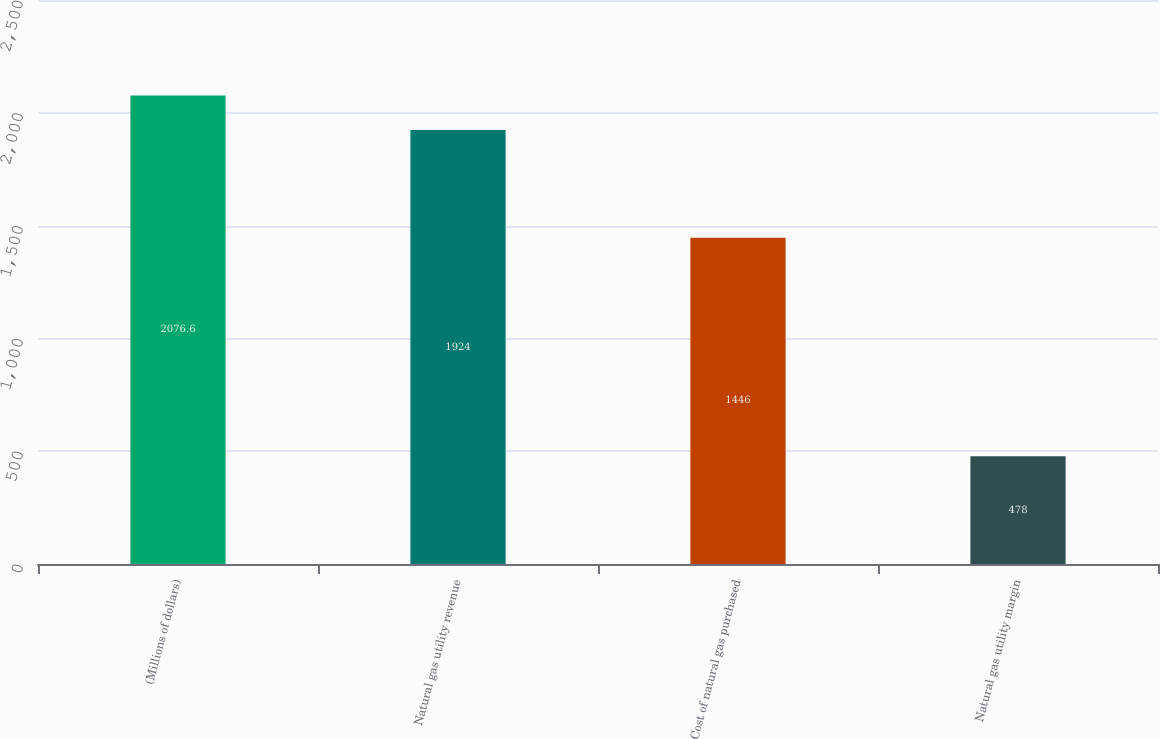<chart> <loc_0><loc_0><loc_500><loc_500><bar_chart><fcel>(Millions of dollars)<fcel>Natural gas utility revenue<fcel>Cost of natural gas purchased<fcel>Natural gas utility margin<nl><fcel>2076.6<fcel>1924<fcel>1446<fcel>478<nl></chart> 